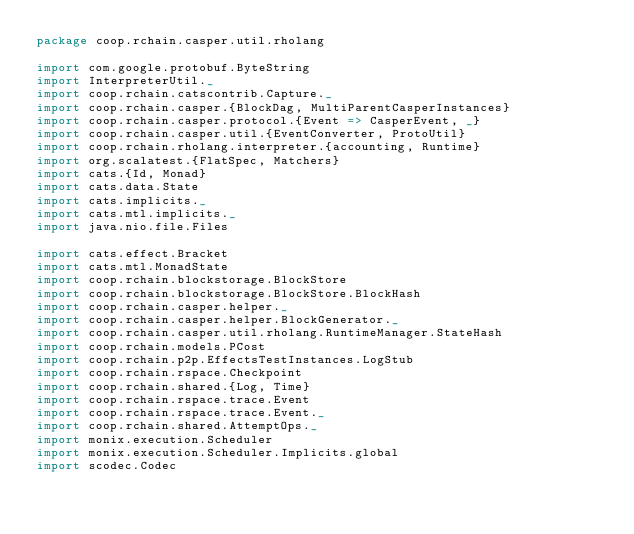Convert code to text. <code><loc_0><loc_0><loc_500><loc_500><_Scala_>package coop.rchain.casper.util.rholang

import com.google.protobuf.ByteString
import InterpreterUtil._
import coop.rchain.catscontrib.Capture._
import coop.rchain.casper.{BlockDag, MultiParentCasperInstances}
import coop.rchain.casper.protocol.{Event => CasperEvent, _}
import coop.rchain.casper.util.{EventConverter, ProtoUtil}
import coop.rchain.rholang.interpreter.{accounting, Runtime}
import org.scalatest.{FlatSpec, Matchers}
import cats.{Id, Monad}
import cats.data.State
import cats.implicits._
import cats.mtl.implicits._
import java.nio.file.Files

import cats.effect.Bracket
import cats.mtl.MonadState
import coop.rchain.blockstorage.BlockStore
import coop.rchain.blockstorage.BlockStore.BlockHash
import coop.rchain.casper.helper._
import coop.rchain.casper.helper.BlockGenerator._
import coop.rchain.casper.util.rholang.RuntimeManager.StateHash
import coop.rchain.models.PCost
import coop.rchain.p2p.EffectsTestInstances.LogStub
import coop.rchain.rspace.Checkpoint
import coop.rchain.shared.{Log, Time}
import coop.rchain.rspace.trace.Event
import coop.rchain.rspace.trace.Event._
import coop.rchain.shared.AttemptOps._
import monix.execution.Scheduler
import monix.execution.Scheduler.Implicits.global
import scodec.Codec
</code> 